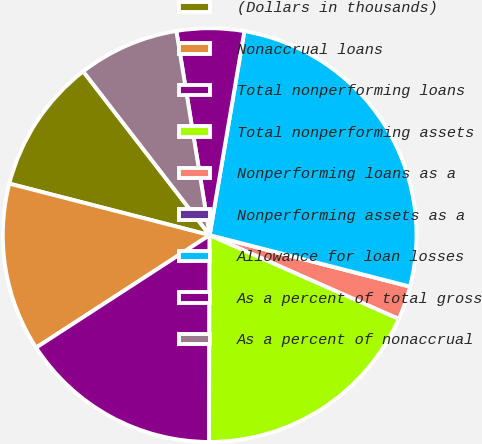<chart> <loc_0><loc_0><loc_500><loc_500><pie_chart><fcel>(Dollars in thousands)<fcel>Nonaccrual loans<fcel>Total nonperforming loans<fcel>Total nonperforming assets<fcel>Nonperforming loans as a<fcel>Nonperforming assets as a<fcel>Allowance for loan losses<fcel>As a percent of total gross<fcel>As a percent of nonaccrual<nl><fcel>10.53%<fcel>13.16%<fcel>15.79%<fcel>18.42%<fcel>2.63%<fcel>0.0%<fcel>26.32%<fcel>5.26%<fcel>7.89%<nl></chart> 